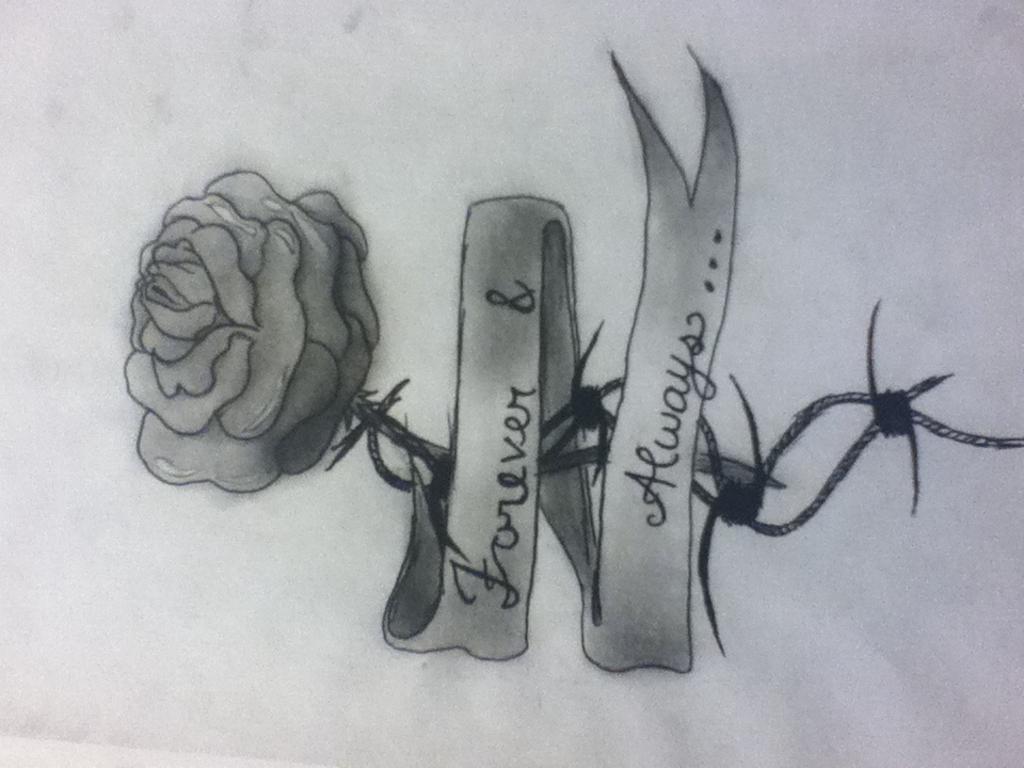In one or two sentences, can you explain what this image depicts? In the picture we can see a drawing of a rose flower with a stem and thorns to it and around it we can see a ribbon with a name on it forever always. 